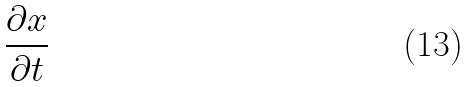<formula> <loc_0><loc_0><loc_500><loc_500>\frac { \partial x } { \partial t }</formula> 